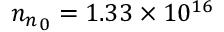<formula> <loc_0><loc_0><loc_500><loc_500>{ n _ { n } } _ { 0 } = 1 . 3 3 \times 1 0 ^ { 1 6 }</formula> 